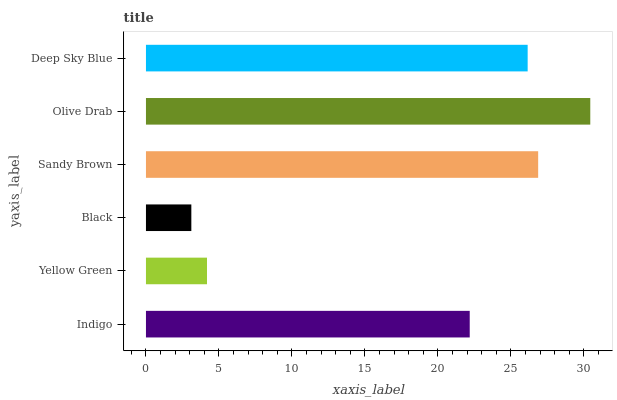Is Black the minimum?
Answer yes or no. Yes. Is Olive Drab the maximum?
Answer yes or no. Yes. Is Yellow Green the minimum?
Answer yes or no. No. Is Yellow Green the maximum?
Answer yes or no. No. Is Indigo greater than Yellow Green?
Answer yes or no. Yes. Is Yellow Green less than Indigo?
Answer yes or no. Yes. Is Yellow Green greater than Indigo?
Answer yes or no. No. Is Indigo less than Yellow Green?
Answer yes or no. No. Is Deep Sky Blue the high median?
Answer yes or no. Yes. Is Indigo the low median?
Answer yes or no. Yes. Is Olive Drab the high median?
Answer yes or no. No. Is Yellow Green the low median?
Answer yes or no. No. 